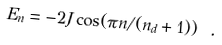<formula> <loc_0><loc_0><loc_500><loc_500>E _ { n } = - 2 J \cos ( \pi n / ( n _ { d } + 1 ) ) \ .</formula> 